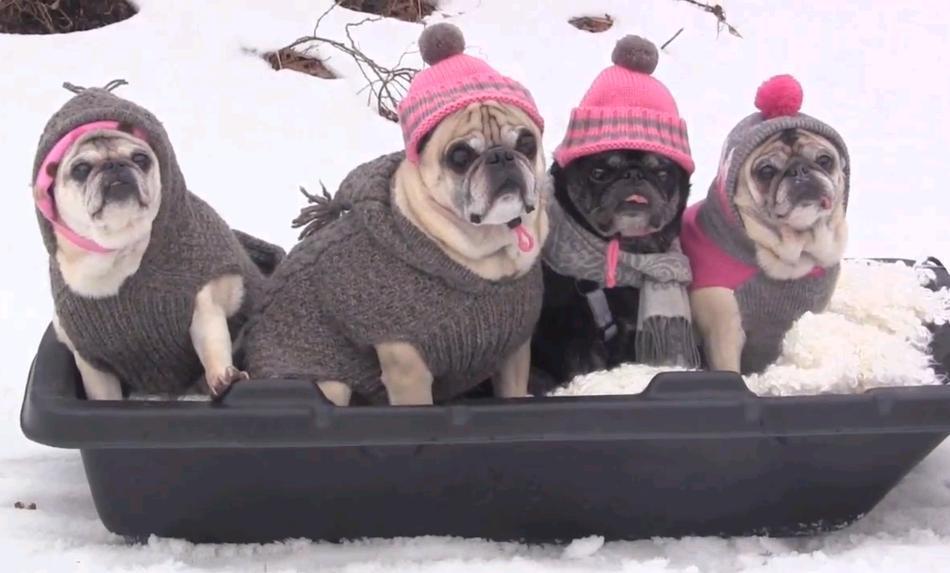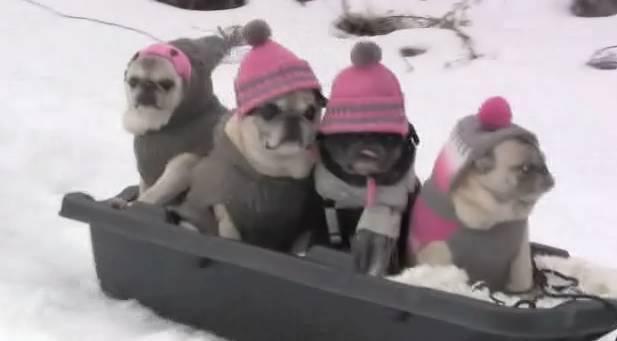The first image is the image on the left, the second image is the image on the right. Given the left and right images, does the statement "There are exactly 8 pugs sitting in a sled wearing hats." hold true? Answer yes or no. Yes. The first image is the image on the left, the second image is the image on the right. For the images shown, is this caption "there is a human in the image on the left" true? Answer yes or no. No. 